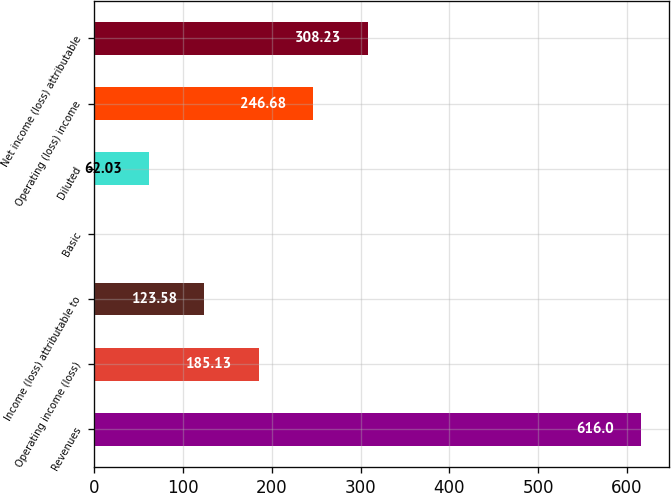Convert chart to OTSL. <chart><loc_0><loc_0><loc_500><loc_500><bar_chart><fcel>Revenues<fcel>Operating income (loss)<fcel>Income (loss) attributable to<fcel>Basic<fcel>Diluted<fcel>Operating (loss) income<fcel>Net income (loss) attributable<nl><fcel>616<fcel>185.13<fcel>123.58<fcel>0.48<fcel>62.03<fcel>246.68<fcel>308.23<nl></chart> 